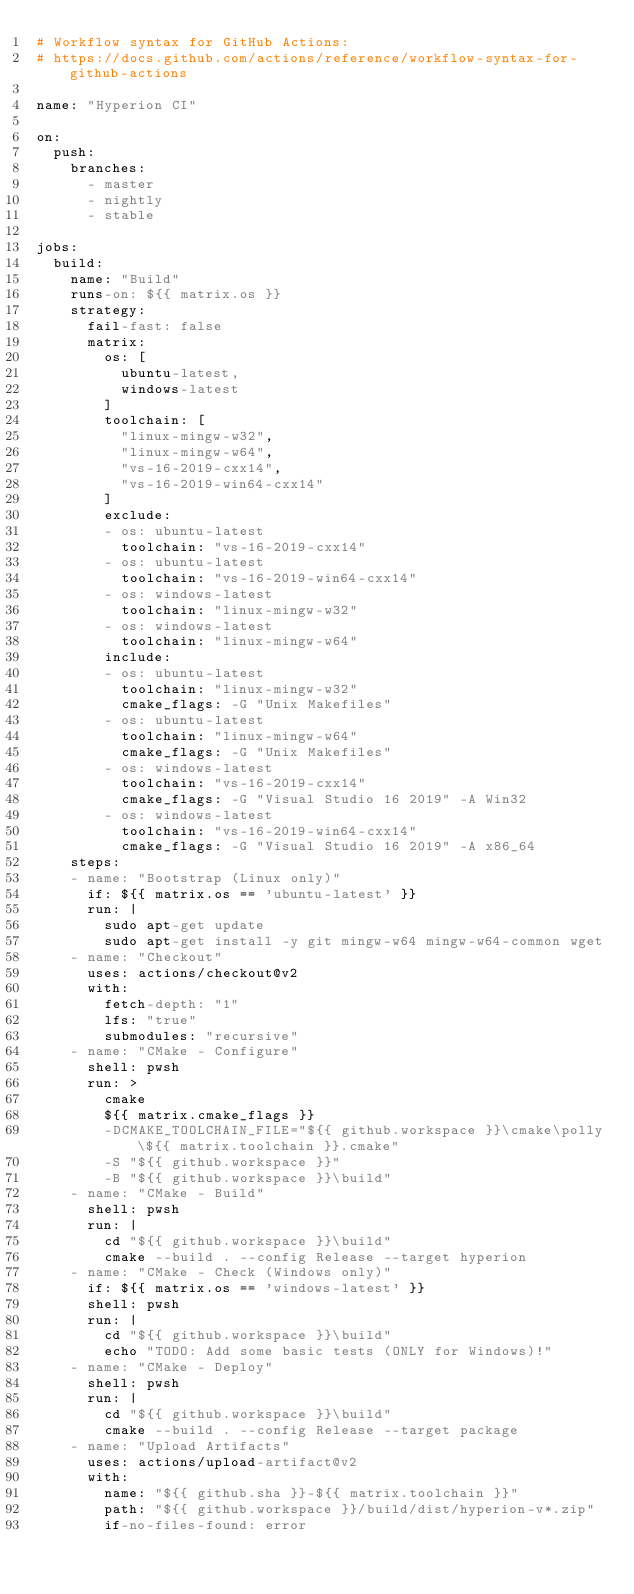Convert code to text. <code><loc_0><loc_0><loc_500><loc_500><_YAML_># Workflow syntax for GitHub Actions:
# https://docs.github.com/actions/reference/workflow-syntax-for-github-actions

name: "Hyperion CI"

on:
  push:
    branches:
      - master
      - nightly
      - stable

jobs:
  build:
    name: "Build"
    runs-on: ${{ matrix.os }}
    strategy:
      fail-fast: false
      matrix:
        os: [
          ubuntu-latest,
          windows-latest
        ]
        toolchain: [
          "linux-mingw-w32",
          "linux-mingw-w64",
          "vs-16-2019-cxx14",
          "vs-16-2019-win64-cxx14"
        ]
        exclude:
        - os: ubuntu-latest
          toolchain: "vs-16-2019-cxx14"
        - os: ubuntu-latest
          toolchain: "vs-16-2019-win64-cxx14"
        - os: windows-latest
          toolchain: "linux-mingw-w32"
        - os: windows-latest
          toolchain: "linux-mingw-w64"
        include:
        - os: ubuntu-latest
          toolchain: "linux-mingw-w32"
          cmake_flags: -G "Unix Makefiles"
        - os: ubuntu-latest
          toolchain: "linux-mingw-w64"
          cmake_flags: -G "Unix Makefiles"
        - os: windows-latest
          toolchain: "vs-16-2019-cxx14"
          cmake_flags: -G "Visual Studio 16 2019" -A Win32
        - os: windows-latest
          toolchain: "vs-16-2019-win64-cxx14"
          cmake_flags: -G "Visual Studio 16 2019" -A x86_64
    steps:
    - name: "Bootstrap (Linux only)"
      if: ${{ matrix.os == 'ubuntu-latest' }}
      run: |
        sudo apt-get update
        sudo apt-get install -y git mingw-w64 mingw-w64-common wget
    - name: "Checkout"
      uses: actions/checkout@v2
      with:
        fetch-depth: "1"
        lfs: "true"
        submodules: "recursive"
    - name: "CMake - Configure"
      shell: pwsh
      run: >
        cmake
        ${{ matrix.cmake_flags }}
        -DCMAKE_TOOLCHAIN_FILE="${{ github.workspace }}\cmake\polly\${{ matrix.toolchain }}.cmake"
        -S "${{ github.workspace }}"
        -B "${{ github.workspace }}\build"
    - name: "CMake - Build"
      shell: pwsh
      run: |
        cd "${{ github.workspace }}\build"
        cmake --build . --config Release --target hyperion
    - name: "CMake - Check (Windows only)"
      if: ${{ matrix.os == 'windows-latest' }}
      shell: pwsh
      run: |
        cd "${{ github.workspace }}\build"
        echo "TODO: Add some basic tests (ONLY for Windows)!"
    - name: "CMake - Deploy"
      shell: pwsh
      run: |
        cd "${{ github.workspace }}\build"
        cmake --build . --config Release --target package
    - name: "Upload Artifacts"
      uses: actions/upload-artifact@v2
      with:
        name: "${{ github.sha }}-${{ matrix.toolchain }}"
        path: "${{ github.workspace }}/build/dist/hyperion-v*.zip"
        if-no-files-found: error
</code> 